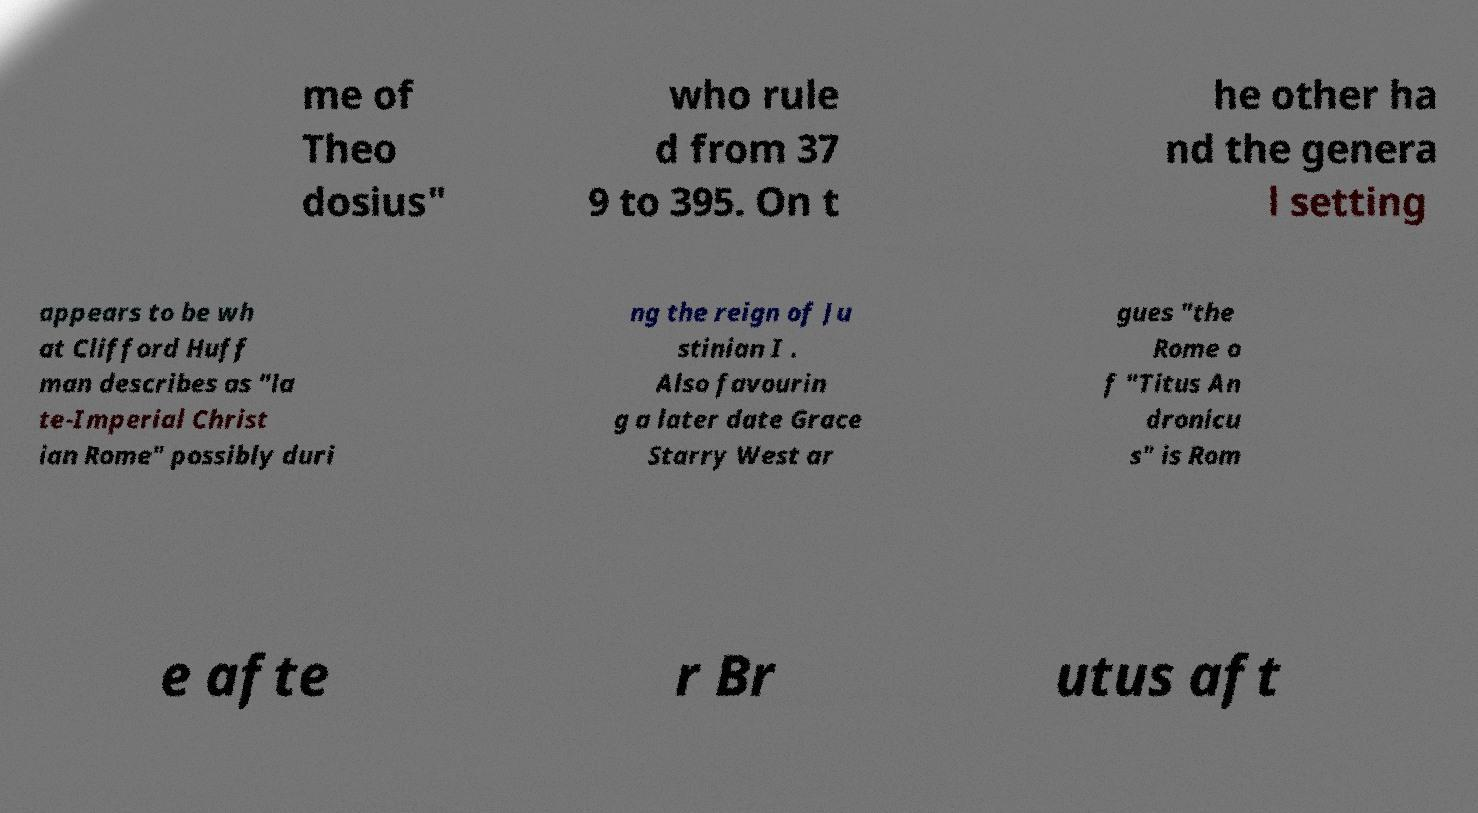There's text embedded in this image that I need extracted. Can you transcribe it verbatim? me of Theo dosius" who rule d from 37 9 to 395. On t he other ha nd the genera l setting appears to be wh at Clifford Huff man describes as "la te-Imperial Christ ian Rome" possibly duri ng the reign of Ju stinian I . Also favourin g a later date Grace Starry West ar gues "the Rome o f "Titus An dronicu s" is Rom e afte r Br utus aft 